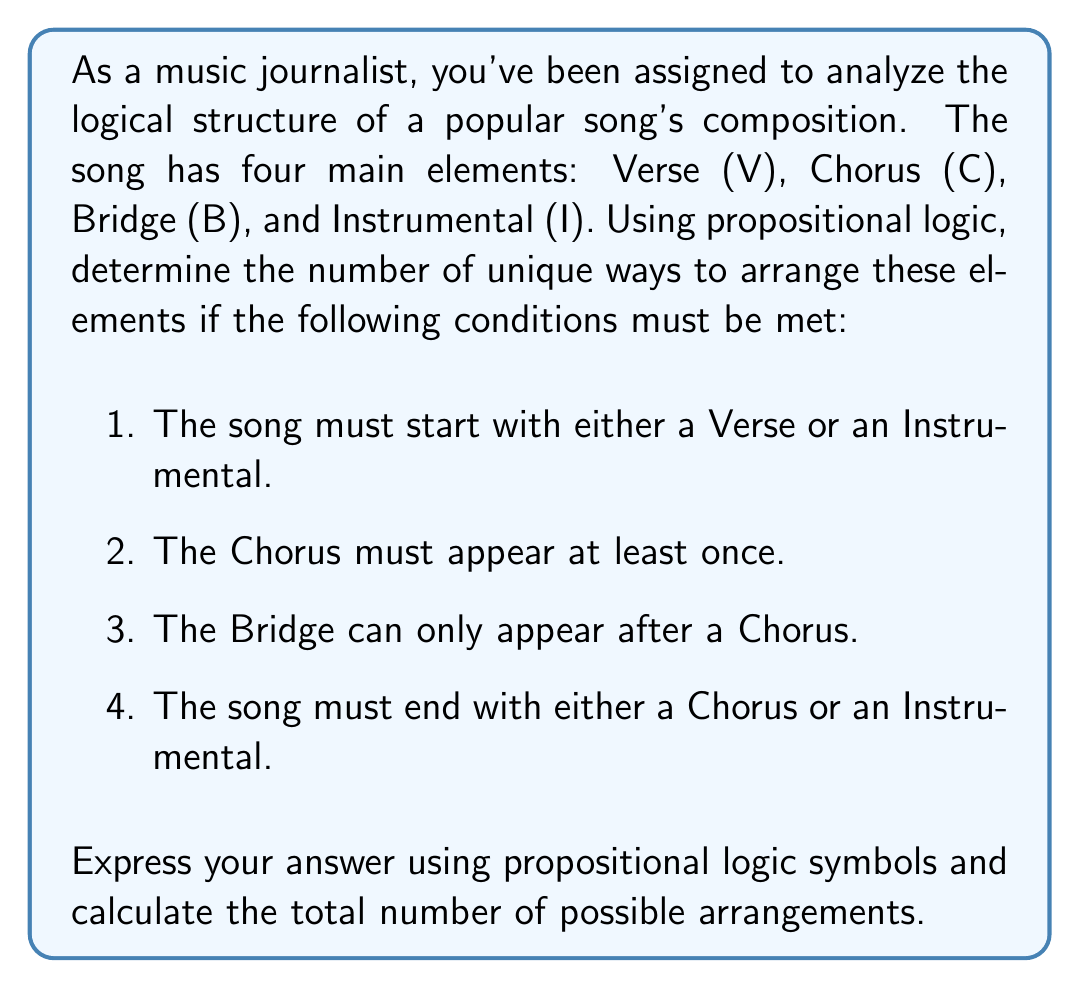Show me your answer to this math problem. Let's approach this step-by-step using propositional logic:

1) First, let's define our propositions:
   V: The composition includes a Verse
   C: The composition includes a Chorus
   B: The composition includes a Bridge
   I: The composition includes an Instrumental

2) Now, let's express the conditions using logical operators:
   Start condition: $V \lor I$
   Chorus condition: $C$
   Bridge condition: $C \rightarrow B$ (if B is true, C must be true before it)
   End condition: $C \lor I$

3) Given these conditions, we can represent a valid composition as:

   $$(V \lor I) \land C \land (C \rightarrow B) \land (C \lor I)$$

4) Now, let's count the possible arrangements:

   a) Starting with V:
      VCVI, VCV, VCBV, VCBI, VCIB, VCBCI
      6 possibilities

   b) Starting with I:
      ICVI, ICV, ICBV, ICBI, ICIB, ICBCI
      6 possibilities

5) The total number of unique arrangements is the sum of these possibilities:

   $$6 + 6 = 12$$

This logical structure ensures that all conditions are met while allowing for various arrangements of the musical elements.
Answer: $$(V \lor I) \land C \land (C \rightarrow B) \land (C \lor I)$$
12 unique arrangements 